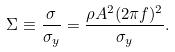Convert formula to latex. <formula><loc_0><loc_0><loc_500><loc_500>\Sigma \equiv \frac { \sigma } { \sigma _ { y } } = \frac { \rho A ^ { 2 } ( 2 \pi f ) ^ { 2 } } { \sigma _ { y } } .</formula> 